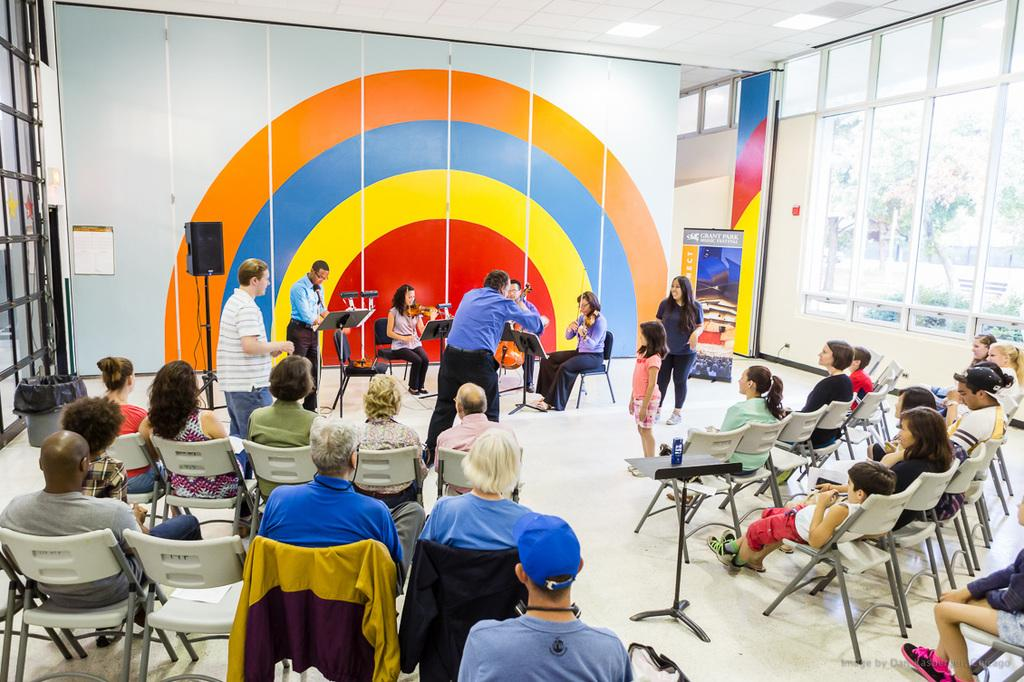What is happening in the image involving a group of people? There is a band of musicians playing music in the image. What are the people around the musicians doing? The people standing around the musicians are likely listening to the music. What are the people sitting in chairs doing? The people sitting in chairs are enjoying the music. How many musicians are in the band? The number of musicians in the band cannot be determined from the provided facts. What is the distance between the musicians and the crack in the wall? There is no mention of a crack in the wall in the provided facts, so it cannot be determined from the image. 